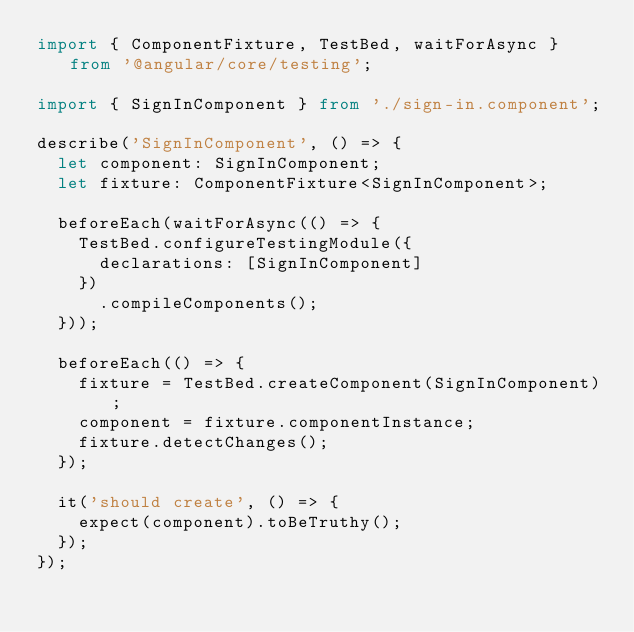Convert code to text. <code><loc_0><loc_0><loc_500><loc_500><_TypeScript_>import { ComponentFixture, TestBed, waitForAsync } from '@angular/core/testing';

import { SignInComponent } from './sign-in.component';

describe('SignInComponent', () => {
  let component: SignInComponent;
  let fixture: ComponentFixture<SignInComponent>;

  beforeEach(waitForAsync(() => {
    TestBed.configureTestingModule({
      declarations: [SignInComponent]
    })
      .compileComponents();
  }));

  beforeEach(() => {
    fixture = TestBed.createComponent(SignInComponent);
    component = fixture.componentInstance;
    fixture.detectChanges();
  });

  it('should create', () => {
    expect(component).toBeTruthy();
  });
});
</code> 